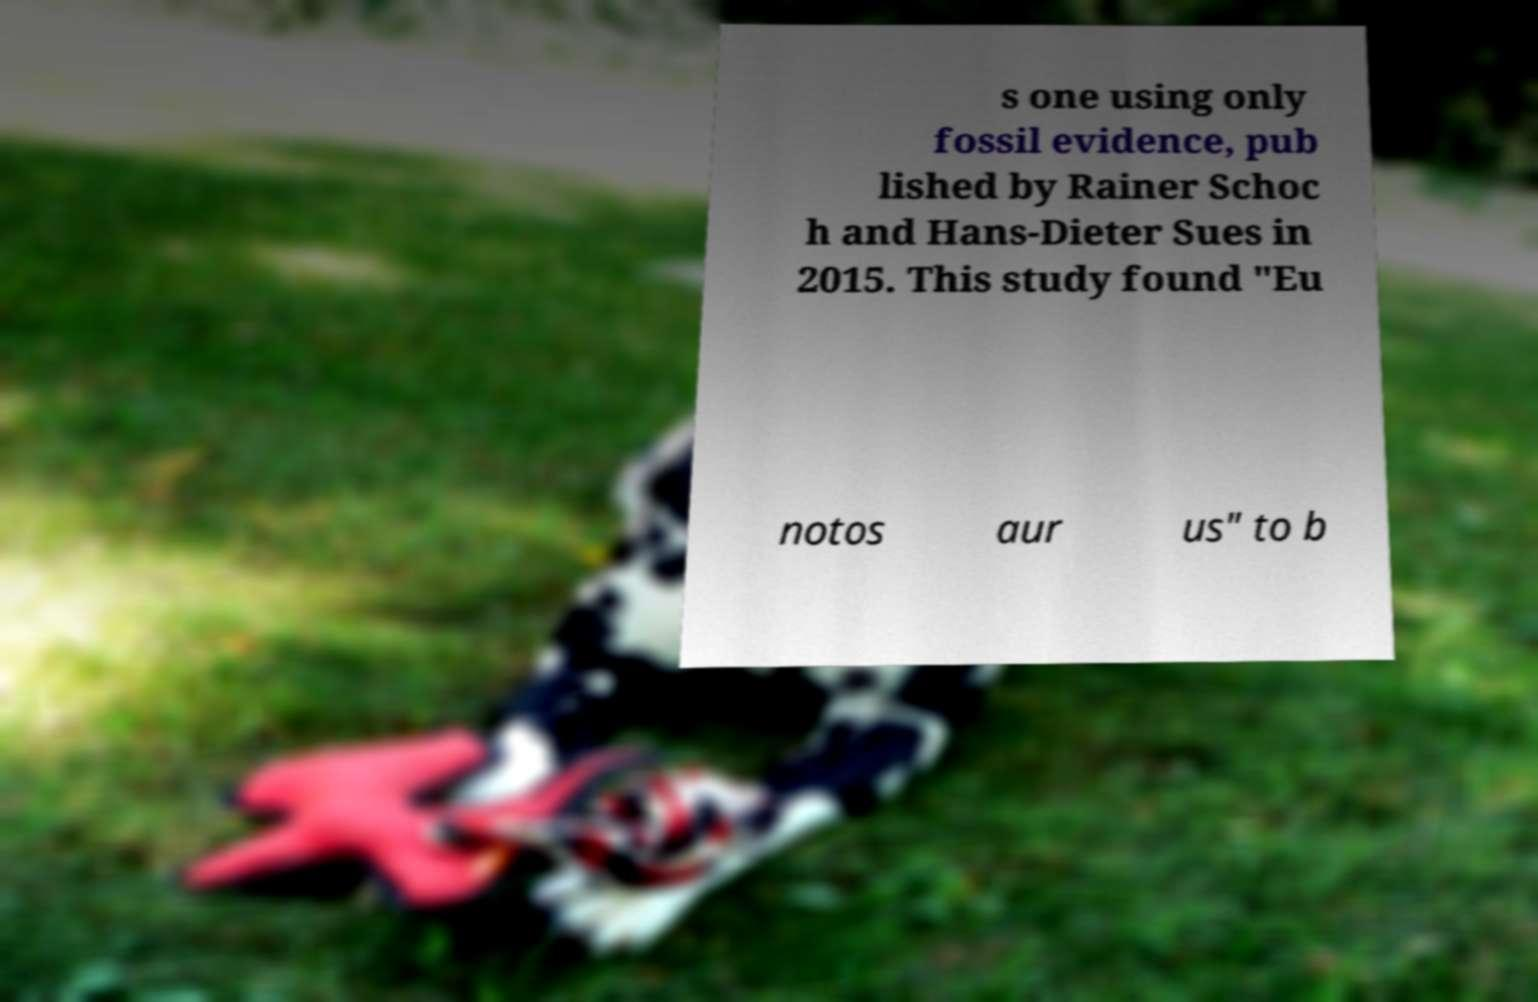Could you assist in decoding the text presented in this image and type it out clearly? s one using only fossil evidence, pub lished by Rainer Schoc h and Hans-Dieter Sues in 2015. This study found "Eu notos aur us" to b 